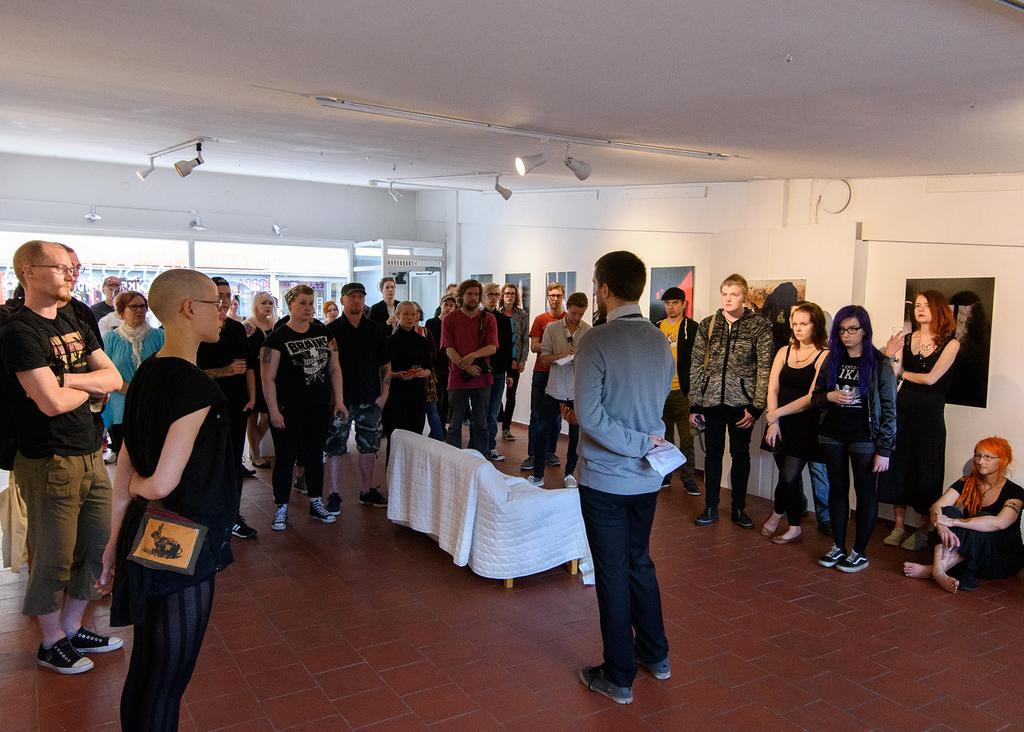Can you describe this image briefly? In this image it seems like the picture is taken inside the room. There is a man standing in the middle and there are people around him. In front of him there is a sofa which is covered with the white colour cloth. At the top there are lights. On the right side there is a wall to which there are frames and posters. 